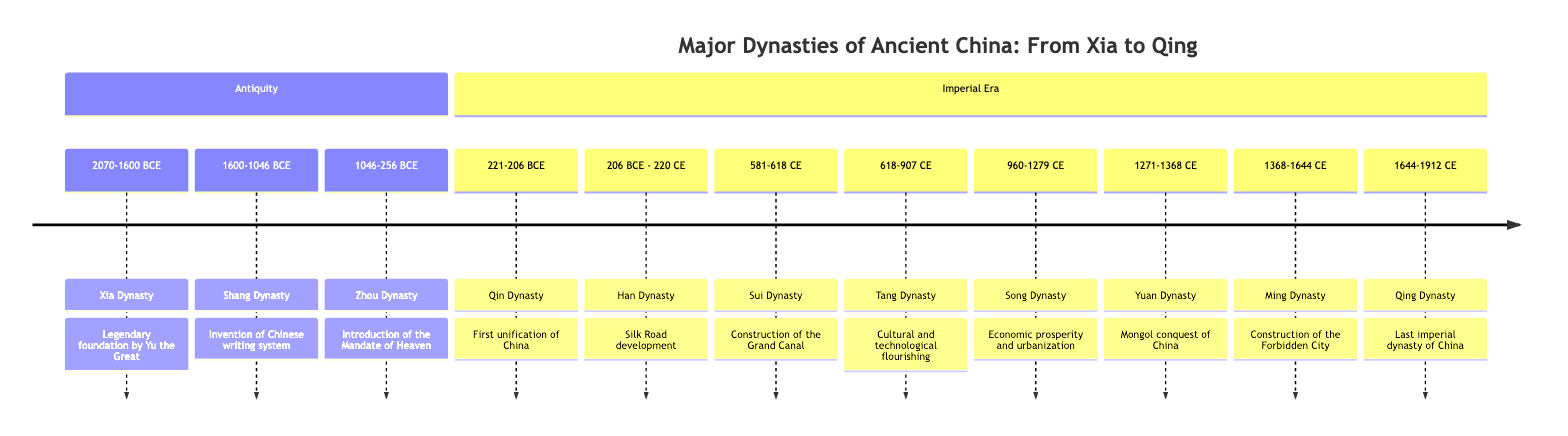What is the period of the Han Dynasty? The diagram shows that the Han Dynasty is represented with the period from 206 BCE to 220 CE.
Answer: 206 BCE - 220 CE What event marks the beginning of the Xia Dynasty? According to the diagram, the event marking the Xia Dynasty's beginning is the "Legendary foundation by Yu the Great."
Answer: Legendary foundation by Yu the Great Which dynasty introduced the Mandate of Heaven? The Zhou Dynasty is shown in the diagram to introduce the Mandate of Heaven as a significant sociopolitical change during its reign.
Answer: Zhou Dynasty What major construction occurred during the Sui Dynasty? The diagram states that the event for the Sui Dynasty is the "Construction of the Grand Canal," indicating a key achievement of this dynasty.
Answer: Construction of the Grand Canal How many dynasties are listed in the timeline? By counting each entry in the timeline section, there are a total of 11 dynasties listed from Xia to Qing.
Answer: 11 What sociopolitical change occurred during the Song Dynasty? The timeline mentions that the Song Dynasty experienced "Introduction of paper money" as its key sociopolitical change, reflecting its economic innovations.
Answer: Introduction of paper money What significant blending of administrative practices occurred during the Yuan Dynasty? The diagram indicates that during the Yuan Dynasty, there was an "Integration of Mongol and Chinese administrative practices," demonstrating the synthesis of cultures in governance.
Answer: Integration of Mongol and Chinese administrative practices Which dynasty is known for the construction of the Forbidden City? According to the diagram, the Ming Dynasty is highlighted for the significant event of "Construction of the Forbidden City."
Answer: Ming Dynasty What was the sociopolitical change during the Qin Dynasty? The diagram illustrates that the Qin Dynasty's sociopolitical change was the establishment of "Centralized imperial rule with standardized laws and measures."
Answer: Centralized imperial rule with standardized laws and measures 